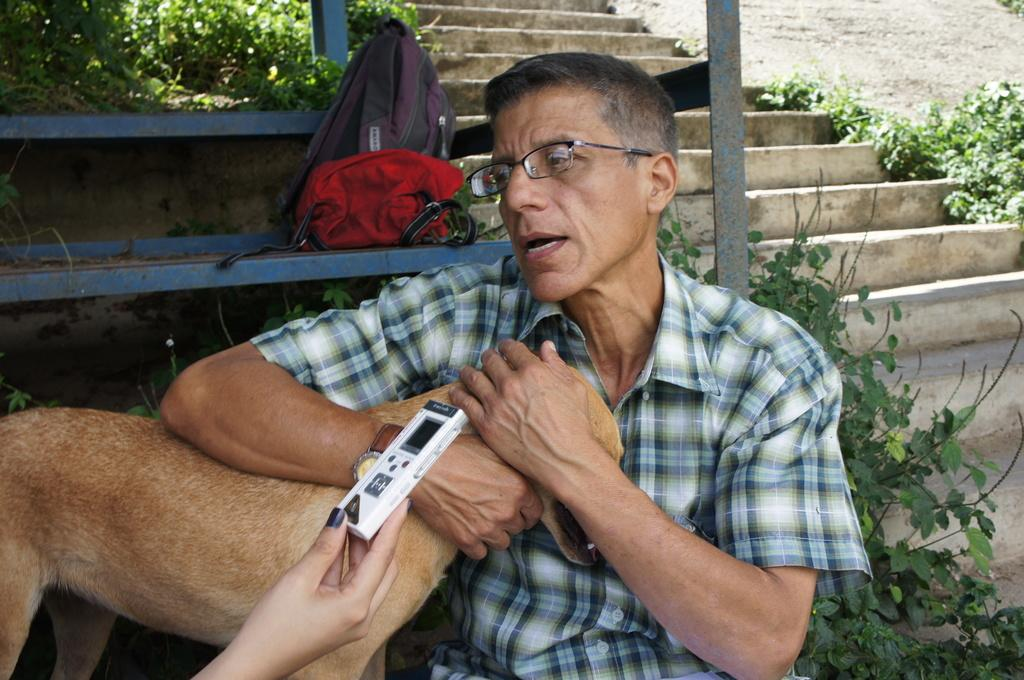What celestial objects are present in the image? There are planets and stars in the image. What can be seen on the metal bench in the image? There are bags on the metal bench. What is the man in the image doing? The man is holding a dog in the image. What device is being held by a human hand in the image? There is a human hand holding a voice recorder in the image. What type of faucet is visible in the image? There is no faucet present in the image. What polish is being applied to the dog in the image? There is no polish being applied to the dog in the image; the man is simply holding the dog. 